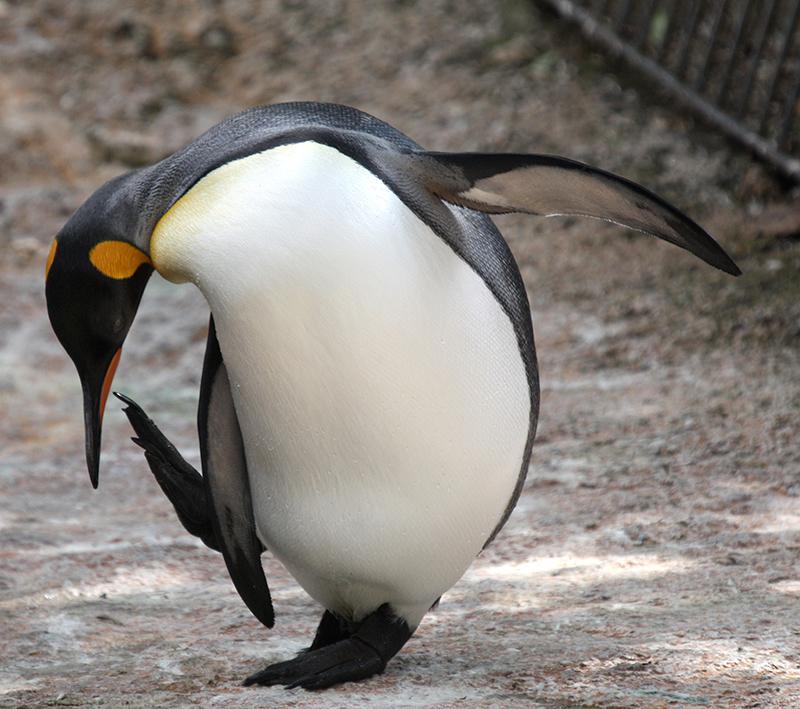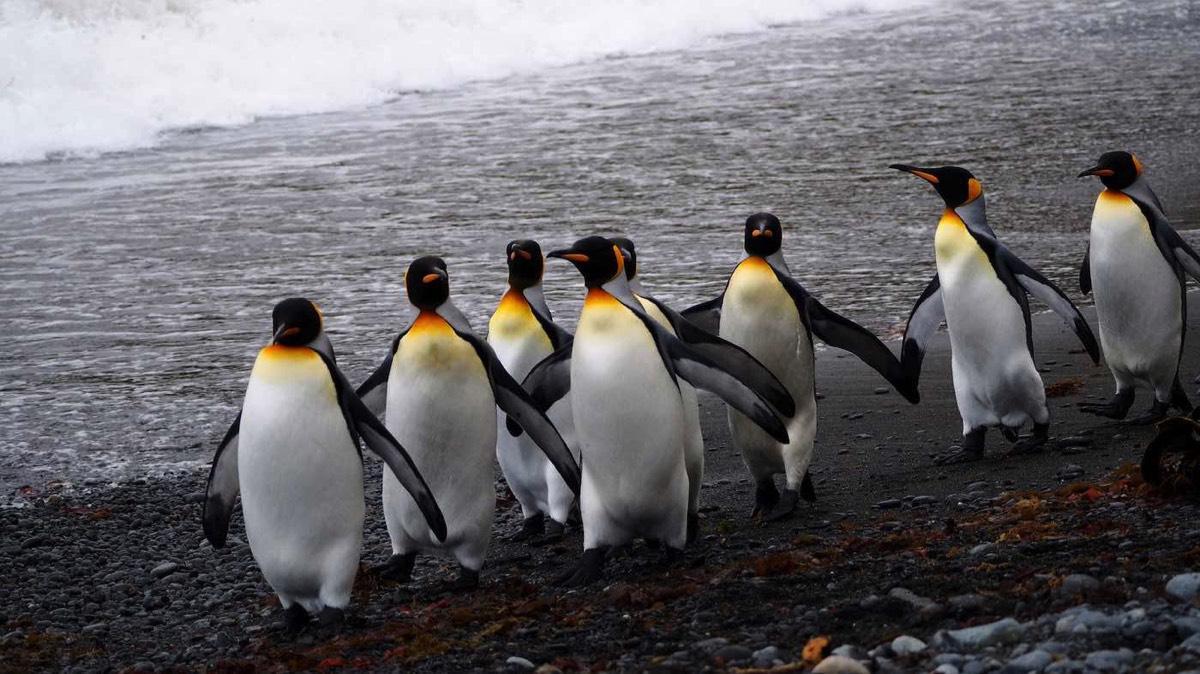The first image is the image on the left, the second image is the image on the right. Examine the images to the left and right. Is the description "One image has one penguin flexing its wings away from its body while its head is facing upwards." accurate? Answer yes or no. No. The first image is the image on the left, the second image is the image on the right. Assess this claim about the two images: "In one of the image a penguin is standing in snow.". Correct or not? Answer yes or no. No. The first image is the image on the left, the second image is the image on the right. Considering the images on both sides, is "One of the images shows a single penguin standing on two legs and facing the left." valid? Answer yes or no. No. The first image is the image on the left, the second image is the image on the right. Evaluate the accuracy of this statement regarding the images: "There are three or fewer penguins in total.". Is it true? Answer yes or no. No. 